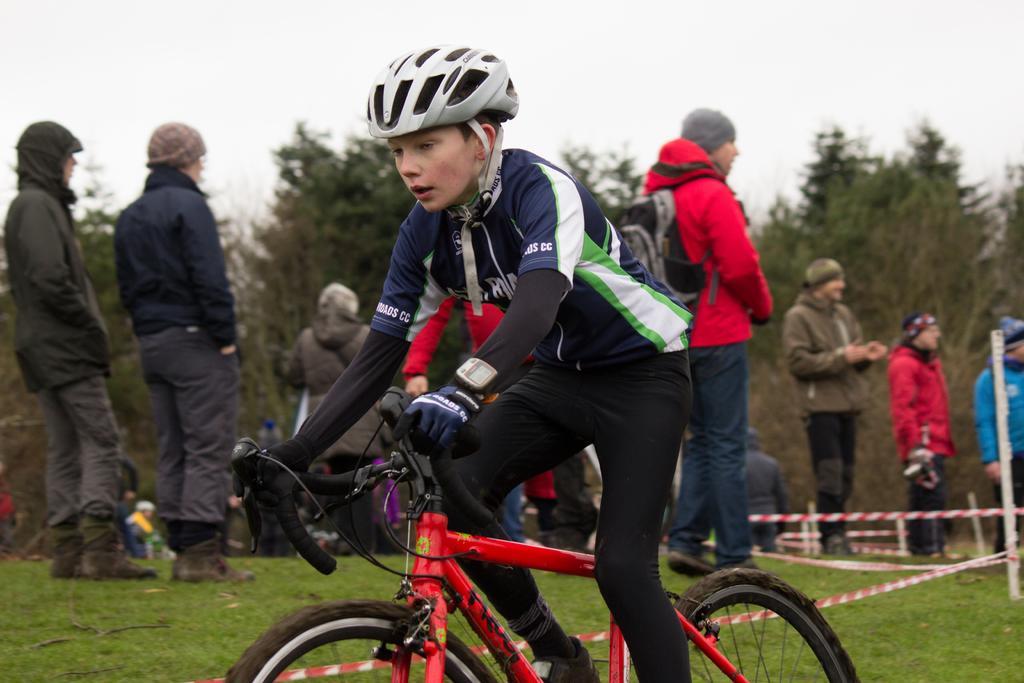Describe this image in one or two sentences. In this image we can see a person and vehicle. In the background of the image there are persons, poles, trees, grass and other objects. At the top of the image there is the sky. 